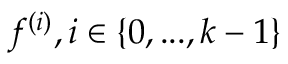<formula> <loc_0><loc_0><loc_500><loc_500>f ^ { ( i ) } , i \in \{ 0 , \dots , k - 1 \}</formula> 